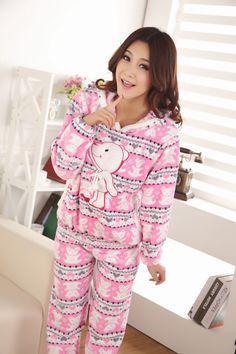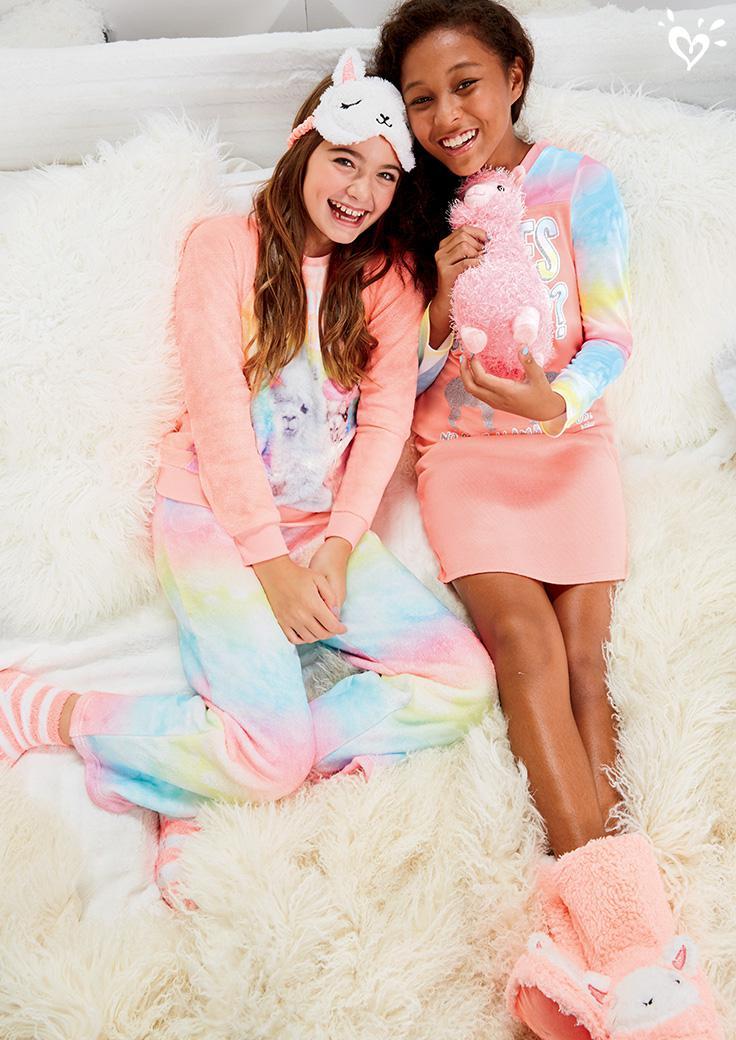The first image is the image on the left, the second image is the image on the right. Assess this claim about the two images: "A woman is holding an armload of slippers in at least one of the images.". Correct or not? Answer yes or no. No. The first image is the image on the left, the second image is the image on the right. Examine the images to the left and right. Is the description "At least one image in the pair shows a woman in pyjamas holding a lot of slippers." accurate? Answer yes or no. No. 